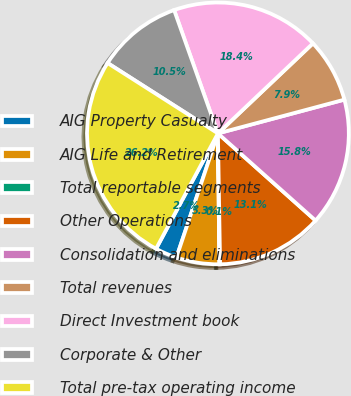Convert chart to OTSL. <chart><loc_0><loc_0><loc_500><loc_500><pie_chart><fcel>AIG Property Casualty<fcel>AIG Life and Retirement<fcel>Total reportable segments<fcel>Other Operations<fcel>Consolidation and eliminations<fcel>Total revenues<fcel>Direct Investment book<fcel>Corporate & Other<fcel>Total pre-tax operating income<nl><fcel>2.7%<fcel>5.31%<fcel>0.09%<fcel>13.14%<fcel>15.75%<fcel>7.92%<fcel>18.36%<fcel>10.53%<fcel>26.2%<nl></chart> 